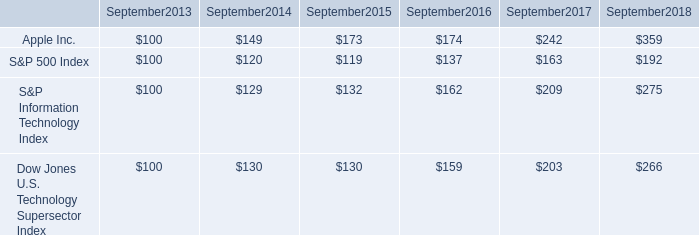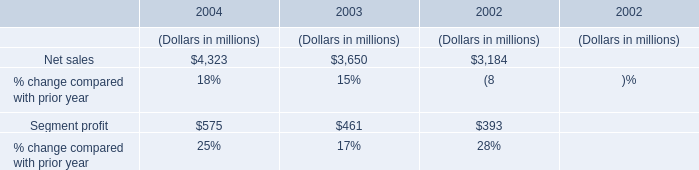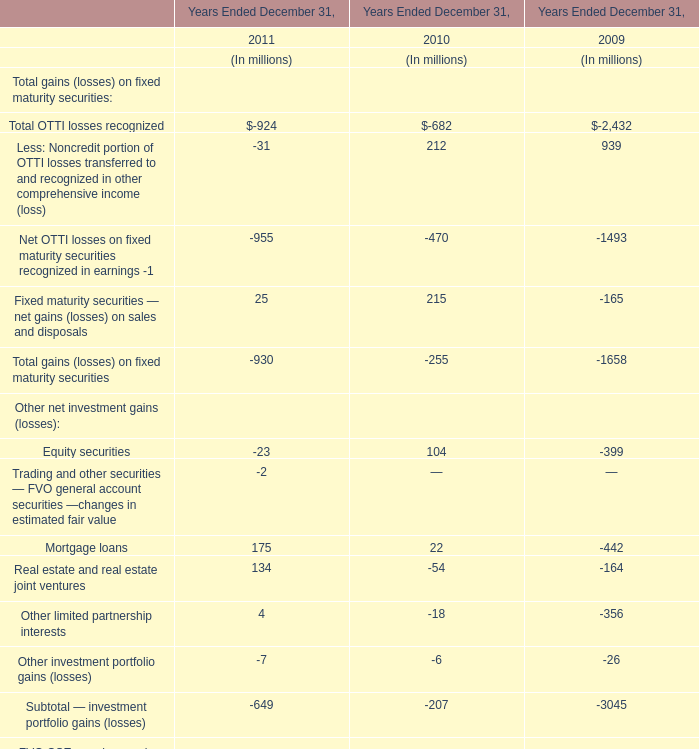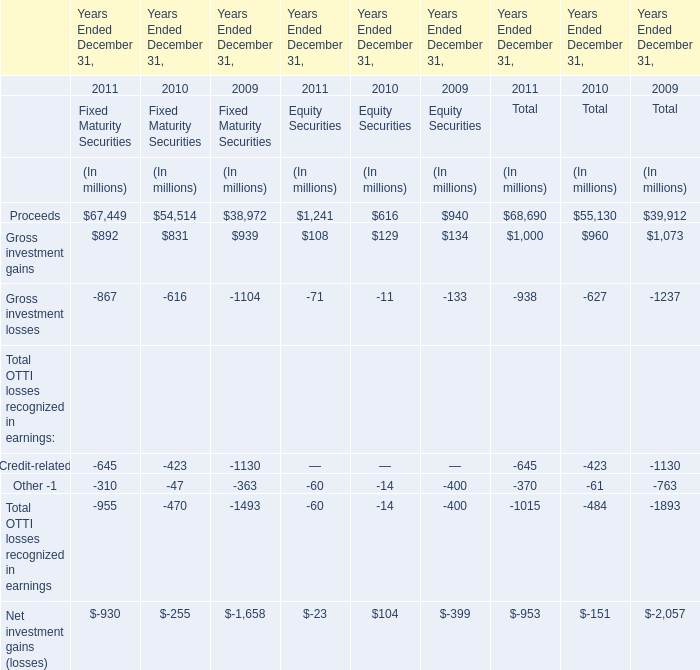what was the percentage cumulative total return for apple inc . for the five year period ended september 2018? 
Computations: ((359 - 100) / 100)
Answer: 2.59. 